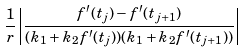<formula> <loc_0><loc_0><loc_500><loc_500>\frac { 1 } { r } \left | \frac { f ^ { \prime } ( t _ { j } ) - f ^ { \prime } ( t _ { j + 1 } ) } { ( k _ { 1 } + k _ { 2 } f ^ { \prime } ( t _ { j } ) ) ( k _ { 1 } + k _ { 2 } f ^ { \prime } ( t _ { j + 1 } ) ) } \right |</formula> 